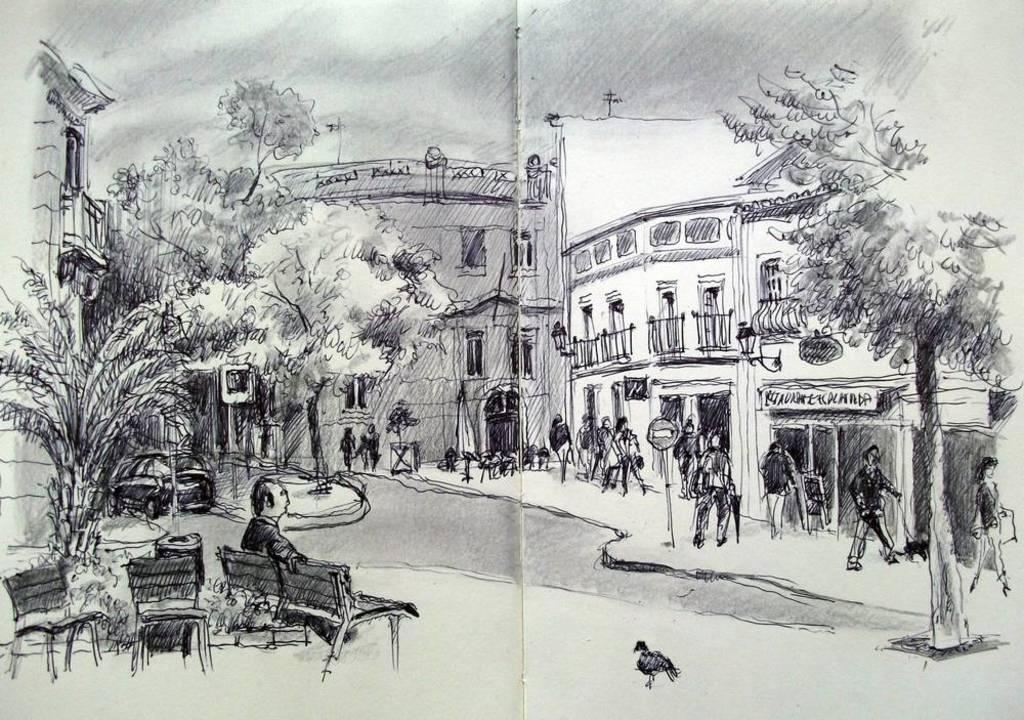How would you summarize this image in a sentence or two? This is the drawing image in which there are persons standing and sitting and there are empty chairs, there are trees, buildings and there is a vehicle and there is a bird in the front and the sky is cloudy. 